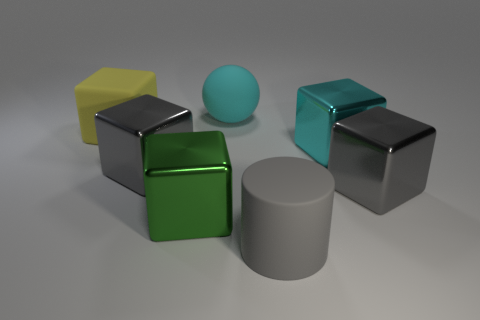There is a large shiny object that is the same color as the sphere; what is its shape?
Your answer should be very brief. Cube. Are there any other things that are the same color as the rubber cylinder?
Keep it short and to the point. Yes. There is a gray block in front of the gray object that is to the left of the big cyan rubber object; what is it made of?
Your answer should be very brief. Metal. What number of other objects are the same material as the green thing?
Provide a succinct answer. 3. Do the yellow object and the big green metallic thing have the same shape?
Your answer should be compact. Yes. Are there fewer things that are behind the big cyan metal thing than green things?
Your answer should be compact. No. What material is the big yellow thing that is the same shape as the green metallic thing?
Give a very brief answer. Rubber. The big shiny thing that is both behind the green object and to the left of the cyan metal cube has what shape?
Your response must be concise. Cube. There is a large cyan object that is made of the same material as the gray cylinder; what shape is it?
Your answer should be compact. Sphere. What is the material of the gray object to the left of the big cyan matte sphere?
Provide a short and direct response. Metal. 